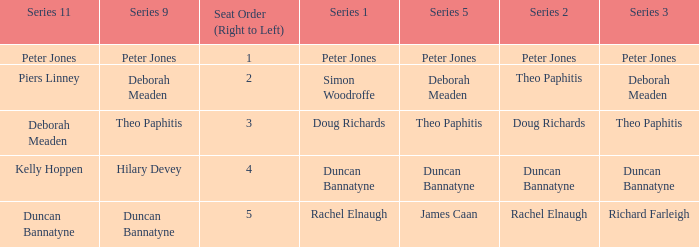Parse the table in full. {'header': ['Series 11', 'Series 9', 'Seat Order (Right to Left)', 'Series 1', 'Series 5', 'Series 2', 'Series 3'], 'rows': [['Peter Jones', 'Peter Jones', '1', 'Peter Jones', 'Peter Jones', 'Peter Jones', 'Peter Jones'], ['Piers Linney', 'Deborah Meaden', '2', 'Simon Woodroffe', 'Deborah Meaden', 'Theo Paphitis', 'Deborah Meaden'], ['Deborah Meaden', 'Theo Paphitis', '3', 'Doug Richards', 'Theo Paphitis', 'Doug Richards', 'Theo Paphitis'], ['Kelly Hoppen', 'Hilary Devey', '4', 'Duncan Bannatyne', 'Duncan Bannatyne', 'Duncan Bannatyne', 'Duncan Bannatyne'], ['Duncan Bannatyne', 'Duncan Bannatyne', '5', 'Rachel Elnaugh', 'James Caan', 'Rachel Elnaugh', 'Richard Farleigh']]} Which Series 1 has a Series 11 of peter jones? Peter Jones. 